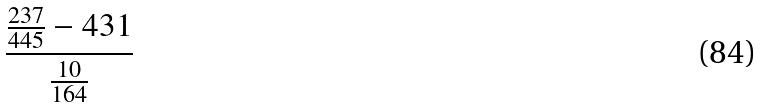<formula> <loc_0><loc_0><loc_500><loc_500>\frac { \frac { 2 3 7 } { 4 4 5 } - 4 3 1 } { \frac { 1 0 } { 1 6 4 } }</formula> 